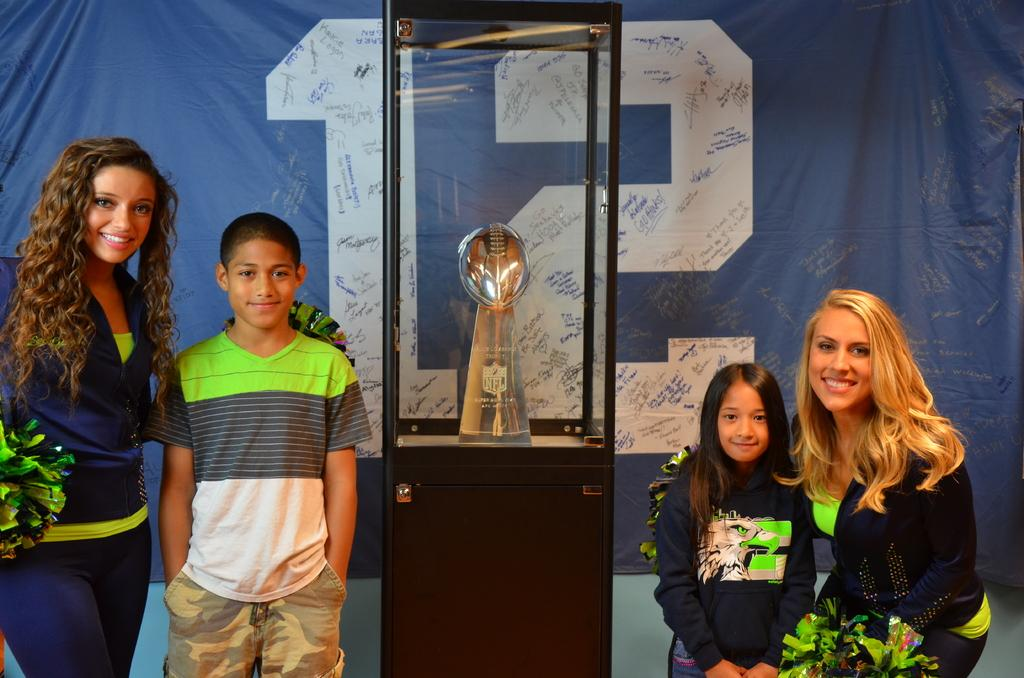How many people are in the image? There are four persons in the image. What is the facial expression of the persons? The persons are smiling. What object is beside the persons? There is a trophy in a box beside the persons. What can be seen in the background of the image? There is a banner in the background of the image. Are there any cattle visible in the image? No, there are no cattle present in the image. What type of plantation can be seen in the background of the image? There is no plantation visible in the image; only a banner is present in the background. 